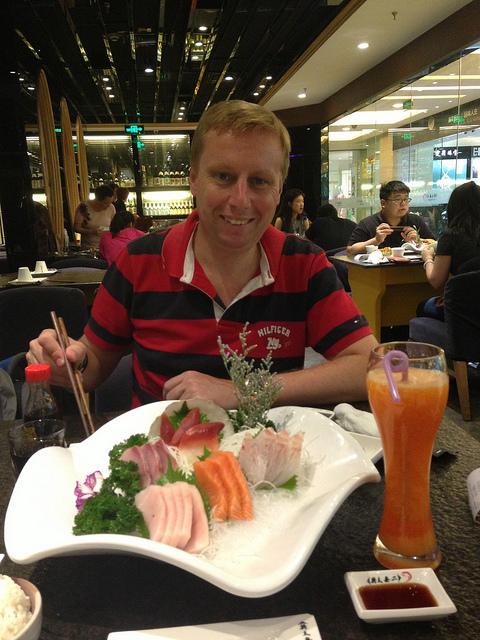How many pieces of salmon are on his plate?
Give a very brief answer. 3. What is the man drinking?
Keep it brief. Juice. Is it crowded?
Be succinct. No. Does this man enjoy sushi?
Be succinct. Yes. What color is his drink?
Answer briefly. Orange. 